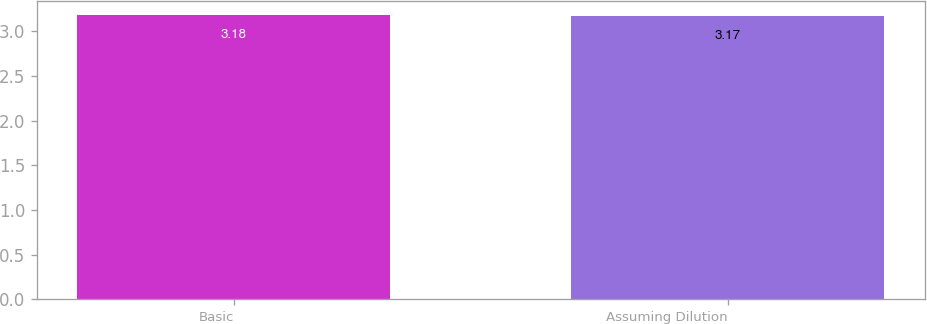Convert chart. <chart><loc_0><loc_0><loc_500><loc_500><bar_chart><fcel>Basic<fcel>Assuming Dilution<nl><fcel>3.18<fcel>3.17<nl></chart> 